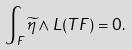Convert formula to latex. <formula><loc_0><loc_0><loc_500><loc_500>\int _ { F } \widetilde { \eta } \wedge L ( T F ) = 0 .</formula> 